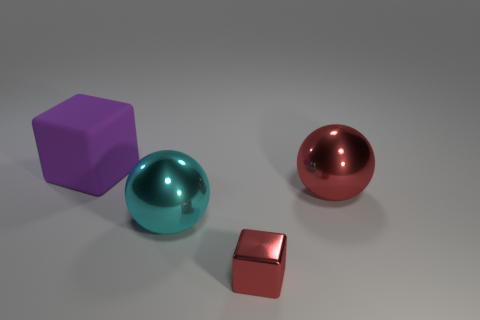Add 2 large gray metallic blocks. How many objects exist? 6 Add 1 big red things. How many big red things are left? 2 Add 4 big red metal objects. How many big red metal objects exist? 5 Subtract 0 yellow cylinders. How many objects are left? 4 Subtract all purple blocks. Subtract all cyan balls. How many blocks are left? 1 Subtract all big purple things. Subtract all small red shiny blocks. How many objects are left? 2 